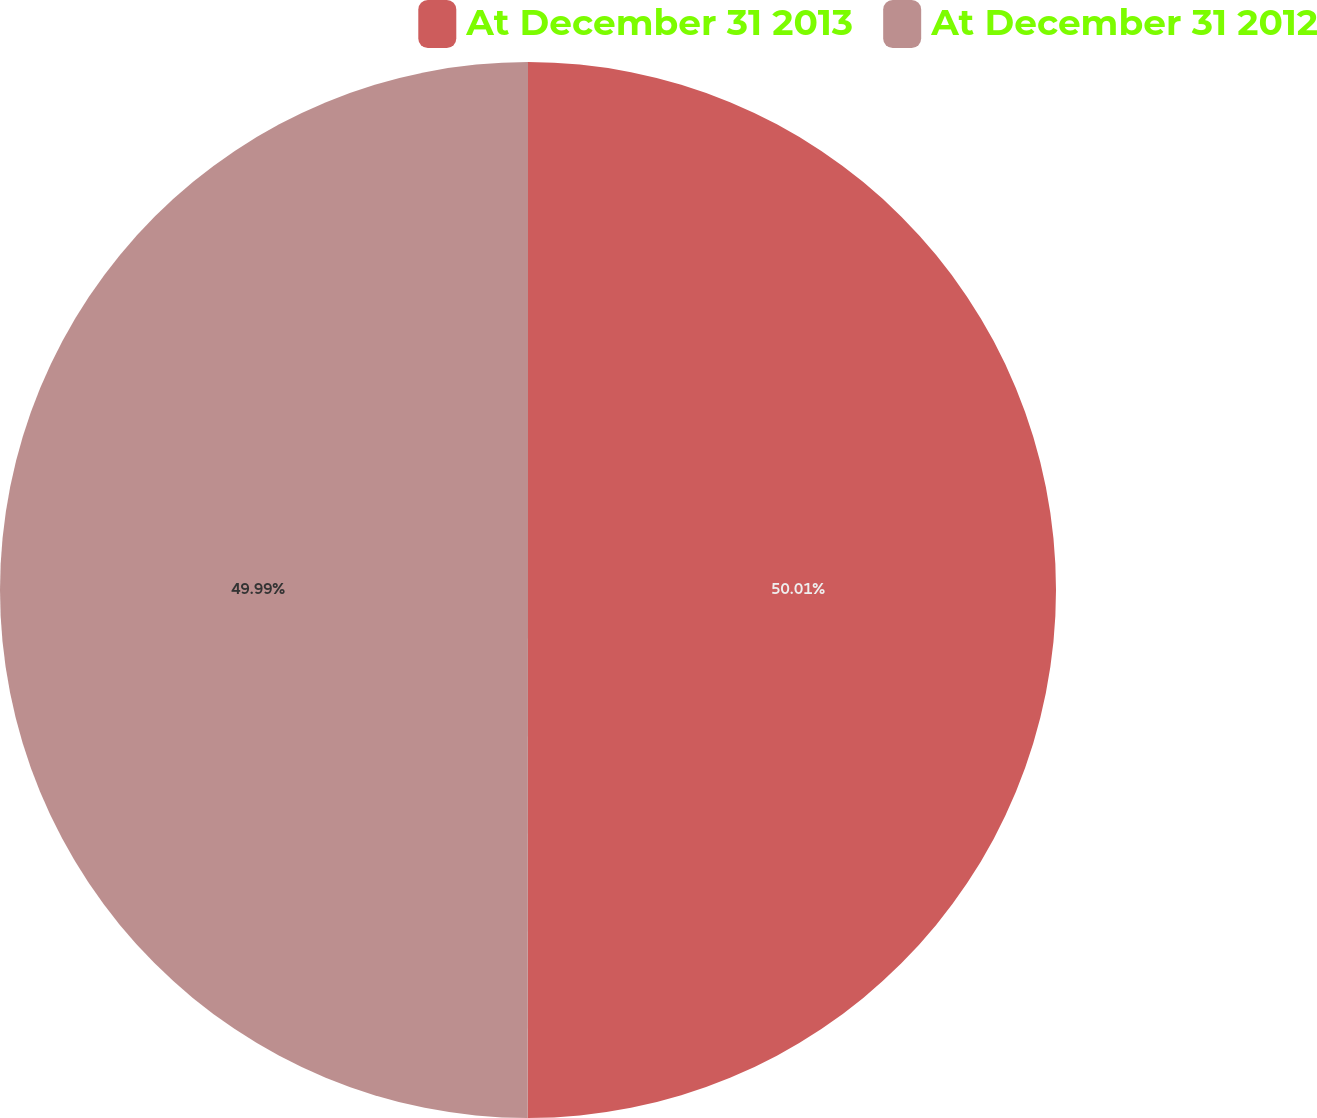Convert chart to OTSL. <chart><loc_0><loc_0><loc_500><loc_500><pie_chart><fcel>At December 31 2013<fcel>At December 31 2012<nl><fcel>50.01%<fcel>49.99%<nl></chart> 